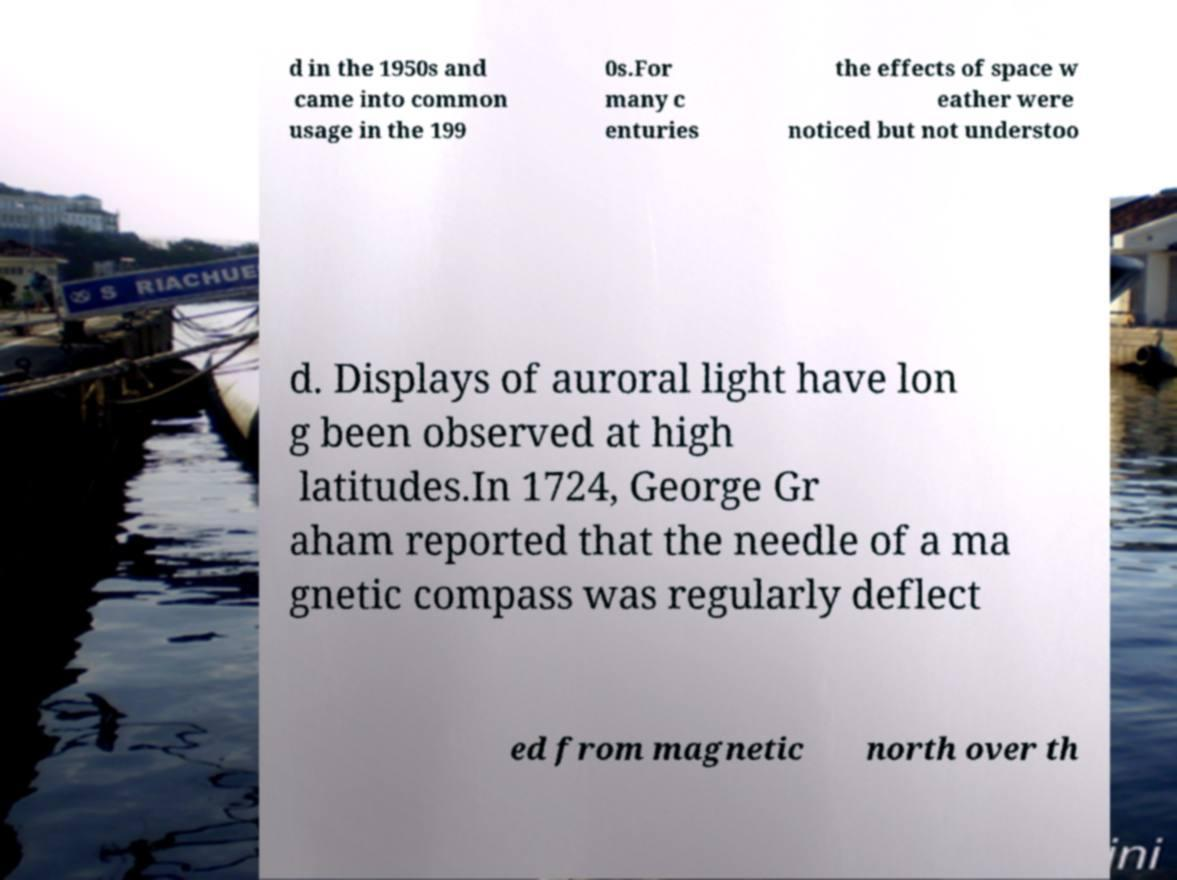Can you accurately transcribe the text from the provided image for me? d in the 1950s and came into common usage in the 199 0s.For many c enturies the effects of space w eather were noticed but not understoo d. Displays of auroral light have lon g been observed at high latitudes.In 1724, George Gr aham reported that the needle of a ma gnetic compass was regularly deflect ed from magnetic north over th 